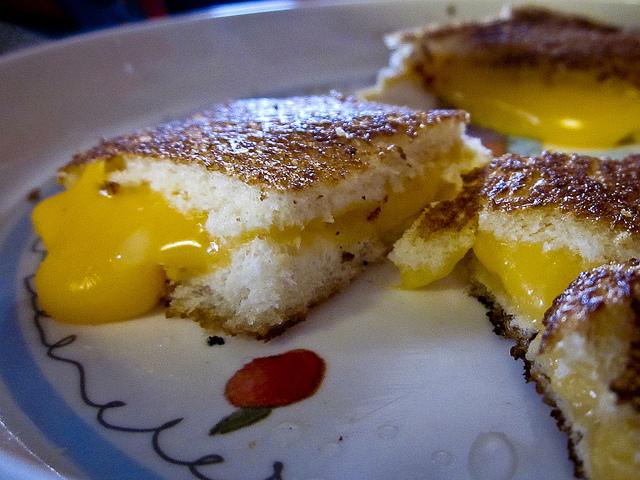Is the pastry on a plate?
Write a very short answer. Yes. What color is the gooey looking stuff?
Keep it brief. Yellow. Does this contain chocolate?
Keep it brief. No. 